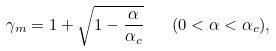Convert formula to latex. <formula><loc_0><loc_0><loc_500><loc_500>\gamma _ { m } = 1 + \sqrt { 1 - \frac { \alpha } { \alpha _ { c } } } \quad ( 0 < \alpha < \alpha _ { c } ) ,</formula> 